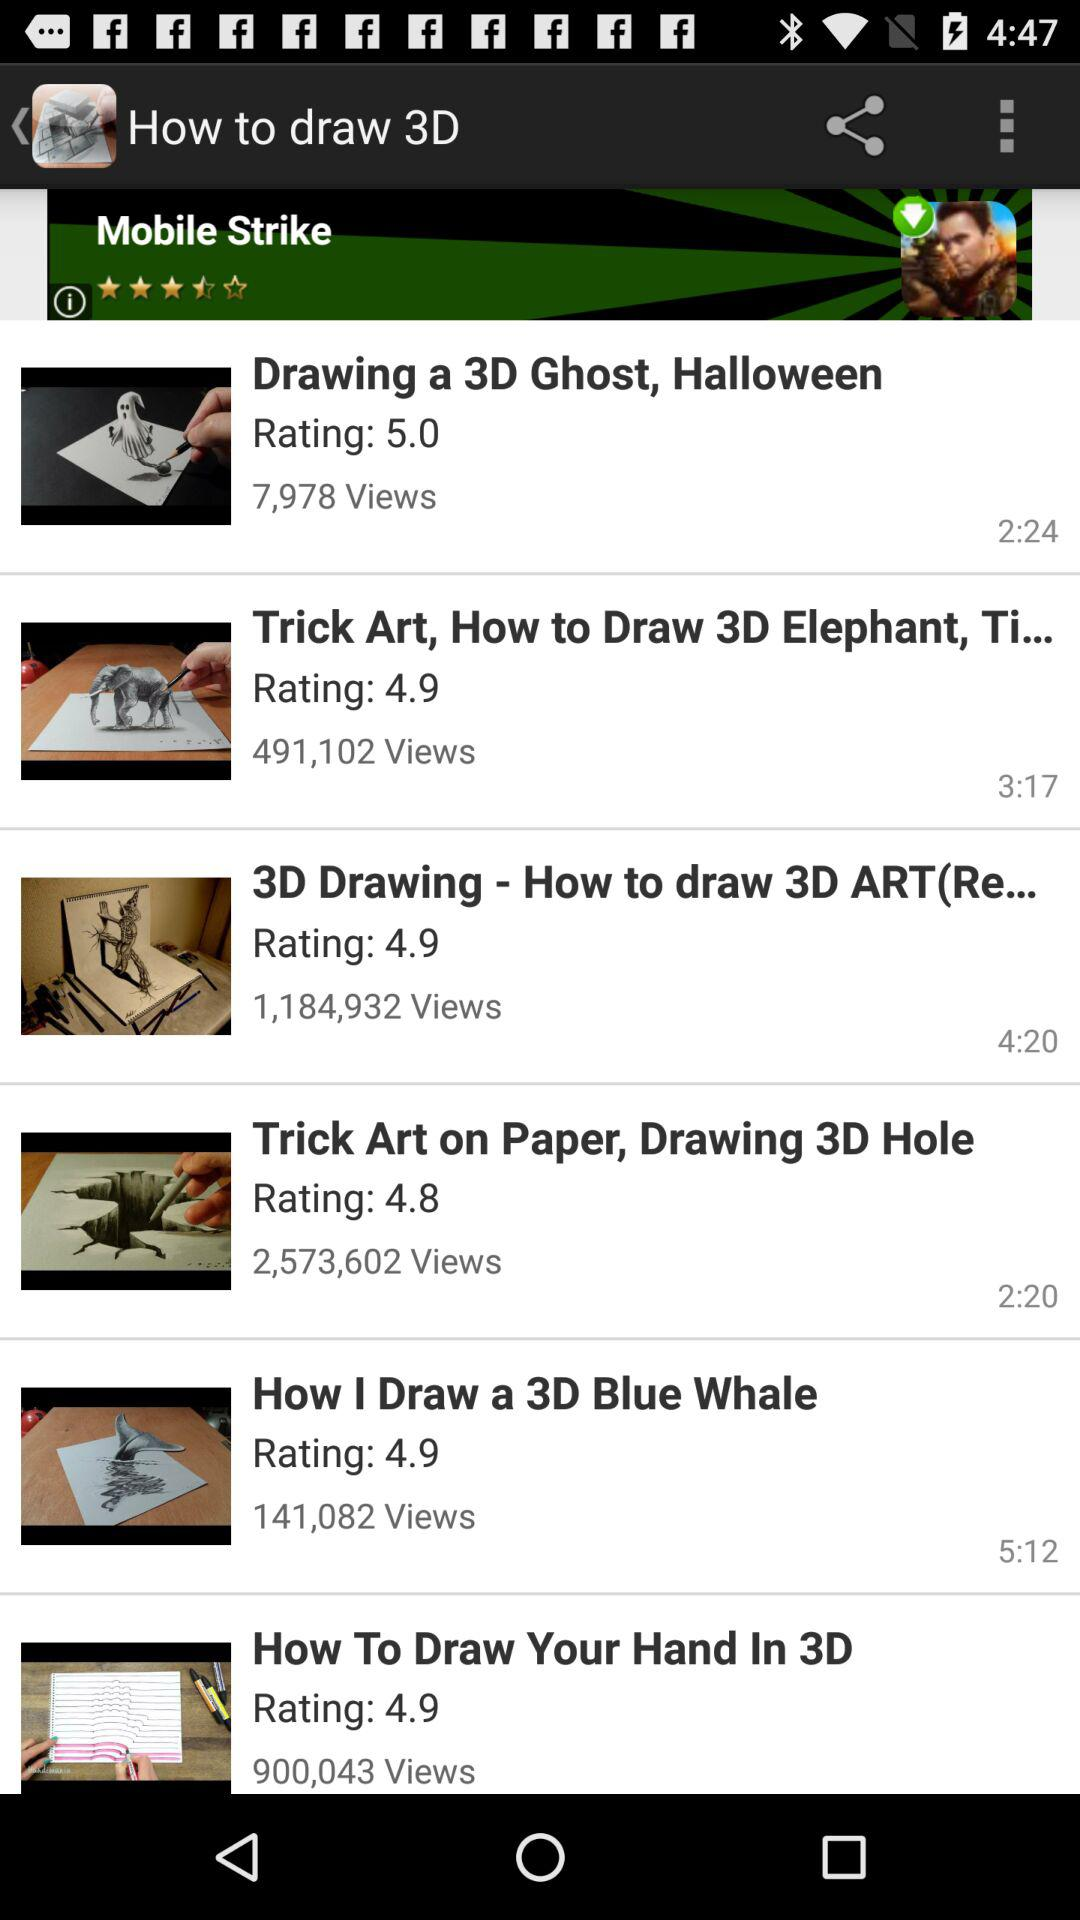How long is the duration of the Trick Art on Paper, Drawing 3D Hole? The duration is 2 minutes and 20 seconds. 